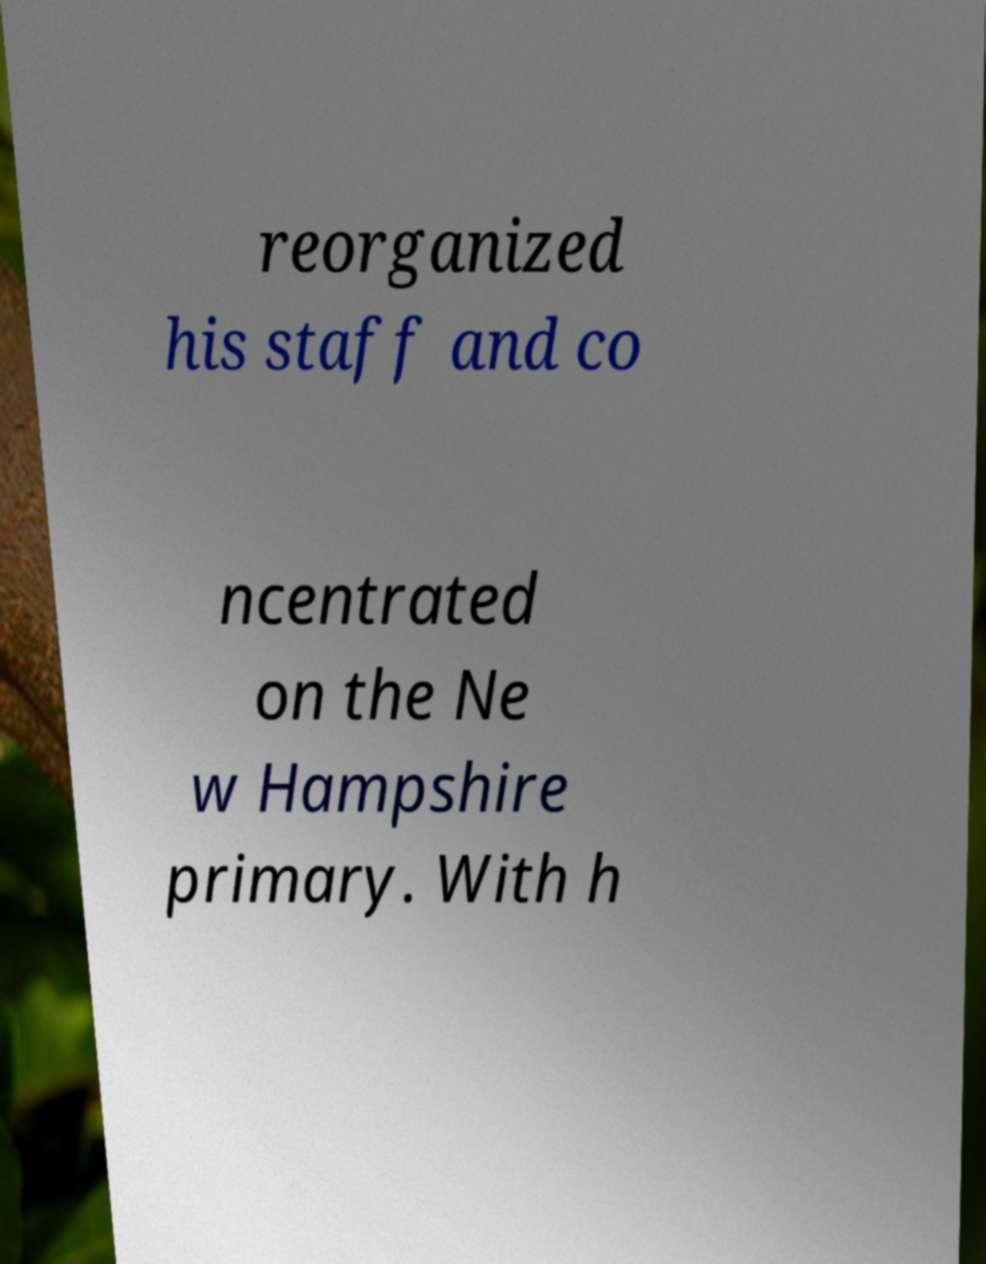There's text embedded in this image that I need extracted. Can you transcribe it verbatim? reorganized his staff and co ncentrated on the Ne w Hampshire primary. With h 